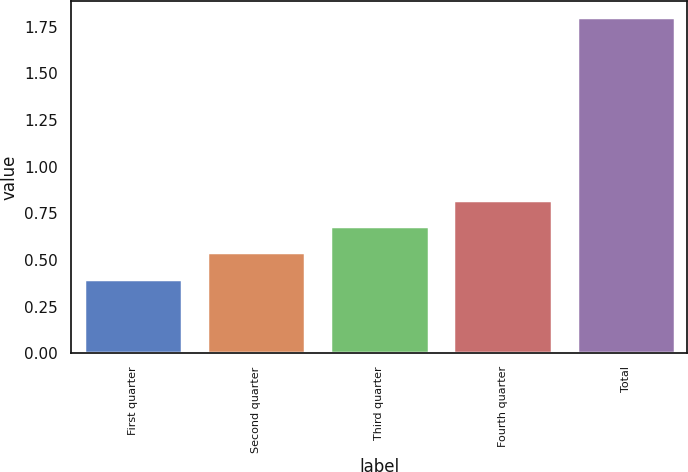Convert chart to OTSL. <chart><loc_0><loc_0><loc_500><loc_500><bar_chart><fcel>First quarter<fcel>Second quarter<fcel>Third quarter<fcel>Fourth quarter<fcel>Total<nl><fcel>0.4<fcel>0.54<fcel>0.68<fcel>0.82<fcel>1.8<nl></chart> 